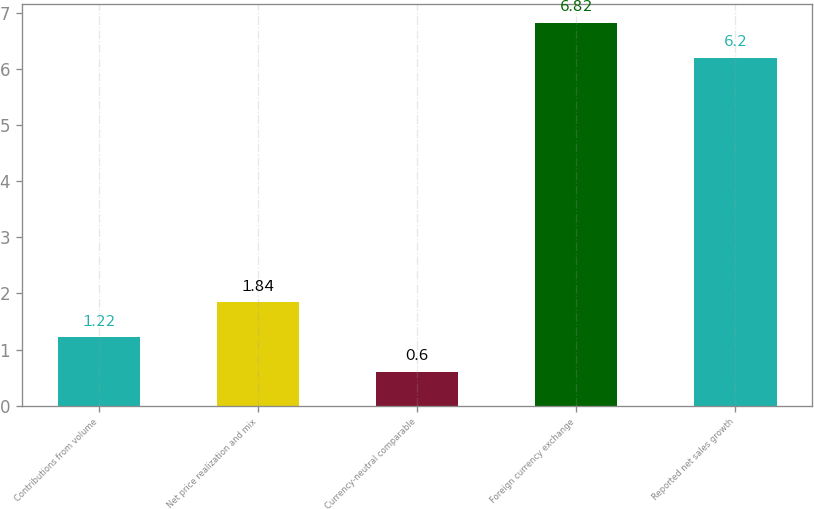Convert chart to OTSL. <chart><loc_0><loc_0><loc_500><loc_500><bar_chart><fcel>Contributions from volume<fcel>Net price realization and mix<fcel>Currency-neutral comparable<fcel>Foreign currency exchange<fcel>Reported net sales growth<nl><fcel>1.22<fcel>1.84<fcel>0.6<fcel>6.82<fcel>6.2<nl></chart> 